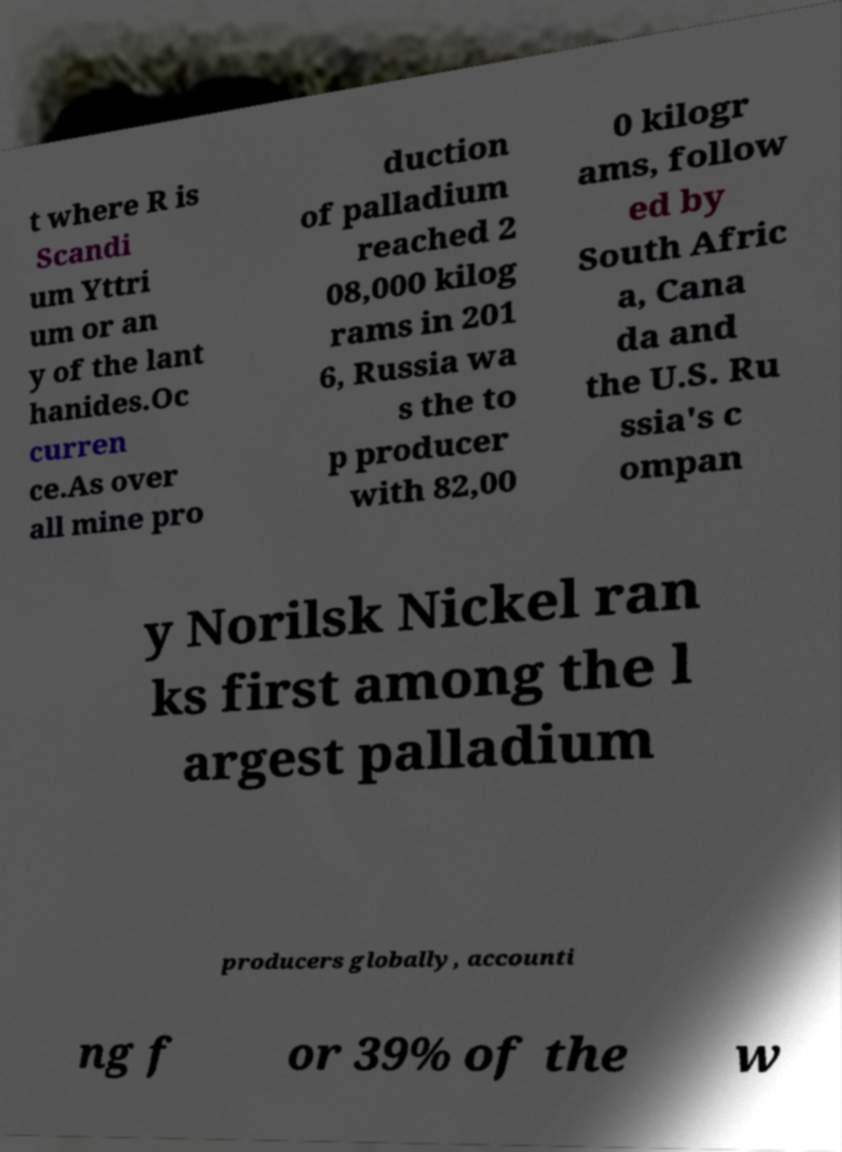Can you accurately transcribe the text from the provided image for me? t where R is Scandi um Yttri um or an y of the lant hanides.Oc curren ce.As over all mine pro duction of palladium reached 2 08,000 kilog rams in 201 6, Russia wa s the to p producer with 82,00 0 kilogr ams, follow ed by South Afric a, Cana da and the U.S. Ru ssia's c ompan y Norilsk Nickel ran ks first among the l argest palladium producers globally, accounti ng f or 39% of the w 